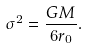Convert formula to latex. <formula><loc_0><loc_0><loc_500><loc_500>\sigma ^ { 2 } = \frac { G M } { 6 r _ { 0 } } .</formula> 